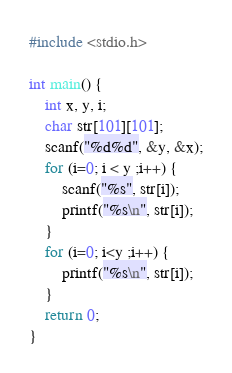Convert code to text. <code><loc_0><loc_0><loc_500><loc_500><_C_>#include <stdio.h>

int main() {
	int x, y, i;
	char str[101][101];
	scanf("%d%d", &y, &x);
	for (i=0; i < y ;i++) {
		scanf("%s", str[i]);
		printf("%s\n", str[i]);
	}
	for (i=0; i<y ;i++) {
		printf("%s\n", str[i]);
	}
	return 0;
}</code> 